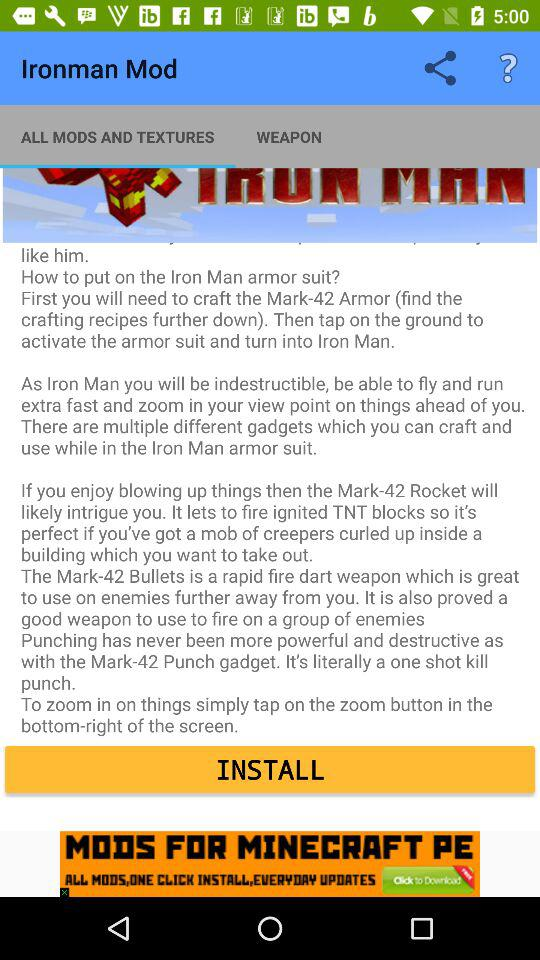Which applications are available for sharing?
When the provided information is insufficient, respond with <no answer>. <no answer> 